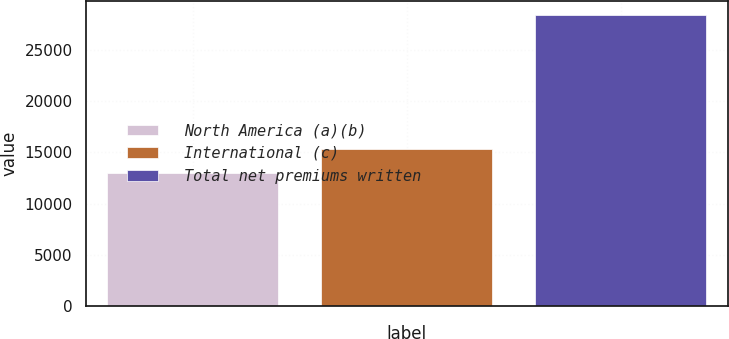Convert chart. <chart><loc_0><loc_0><loc_500><loc_500><bar_chart><fcel>North America (a)(b)<fcel>International (c)<fcel>Total net premiums written<nl><fcel>13026<fcel>15367<fcel>28393<nl></chart> 